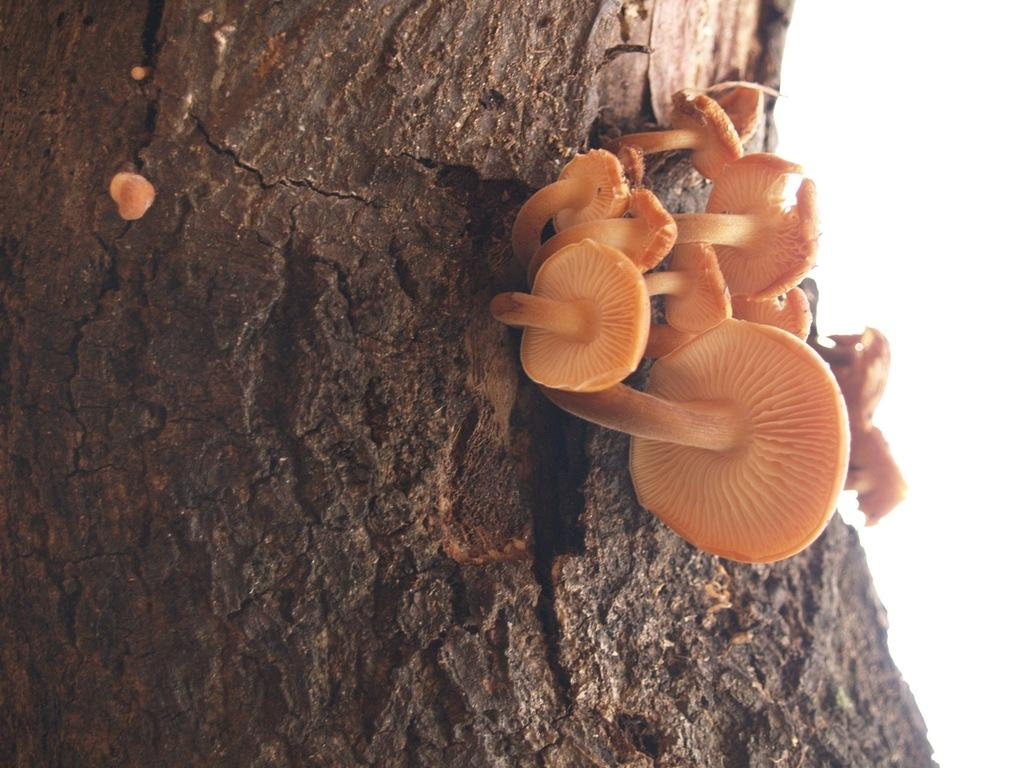What type of fungi can be seen on the tree trunk in the image? There are mushrooms on the tree trunk in the image. What color are the mushrooms? The mushrooms are in orange color. What part of the natural environment is visible in the image? The sky is visible at the top of the image. What type of transport can be seen on the island in the image? There is no island or transport present in the image; it features mushrooms on a tree trunk and a visible sky. What form does the island take in the image? There is no island present in the image, so it is not possible to describe its form. 